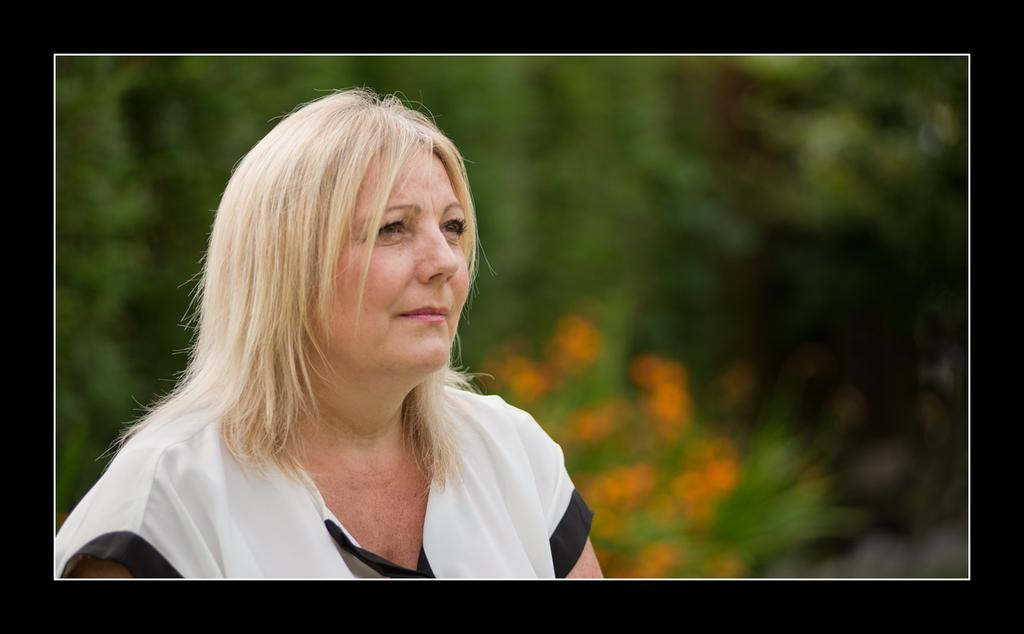Who is the main subject in the image? There is a woman in the image. What can be seen in the background of the image? The background of the image is green and blurred. What color is the border of the image? The image has a border with black color. How many tomatoes can be seen in the image? There are no tomatoes present in the image. What time of day is it in the image? The time of day cannot be determined from the image, as there is no information about the lighting or shadows. 